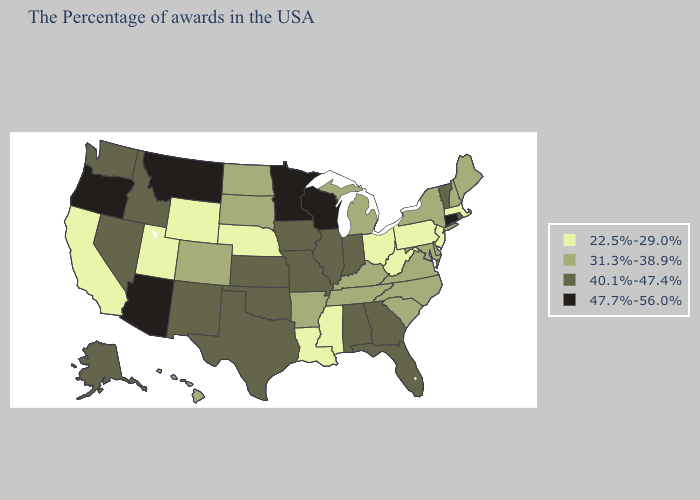Does Illinois have the same value as Arkansas?
Quick response, please. No. What is the highest value in the USA?
Quick response, please. 47.7%-56.0%. What is the highest value in the USA?
Concise answer only. 47.7%-56.0%. Name the states that have a value in the range 47.7%-56.0%?
Write a very short answer. Connecticut, Wisconsin, Minnesota, Montana, Arizona, Oregon. Name the states that have a value in the range 47.7%-56.0%?
Short answer required. Connecticut, Wisconsin, Minnesota, Montana, Arizona, Oregon. Name the states that have a value in the range 40.1%-47.4%?
Give a very brief answer. Rhode Island, Vermont, Florida, Georgia, Indiana, Alabama, Illinois, Missouri, Iowa, Kansas, Oklahoma, Texas, New Mexico, Idaho, Nevada, Washington, Alaska. Does South Carolina have a lower value than Illinois?
Short answer required. Yes. Does North Dakota have the highest value in the USA?
Concise answer only. No. Does West Virginia have the lowest value in the USA?
Be succinct. Yes. Which states hav the highest value in the MidWest?
Answer briefly. Wisconsin, Minnesota. Name the states that have a value in the range 31.3%-38.9%?
Concise answer only. Maine, New Hampshire, New York, Delaware, Maryland, Virginia, North Carolina, South Carolina, Michigan, Kentucky, Tennessee, Arkansas, South Dakota, North Dakota, Colorado, Hawaii. Name the states that have a value in the range 22.5%-29.0%?
Quick response, please. Massachusetts, New Jersey, Pennsylvania, West Virginia, Ohio, Mississippi, Louisiana, Nebraska, Wyoming, Utah, California. Does Wyoming have the lowest value in the USA?
Be succinct. Yes. How many symbols are there in the legend?
Write a very short answer. 4. What is the value of Wyoming?
Give a very brief answer. 22.5%-29.0%. 